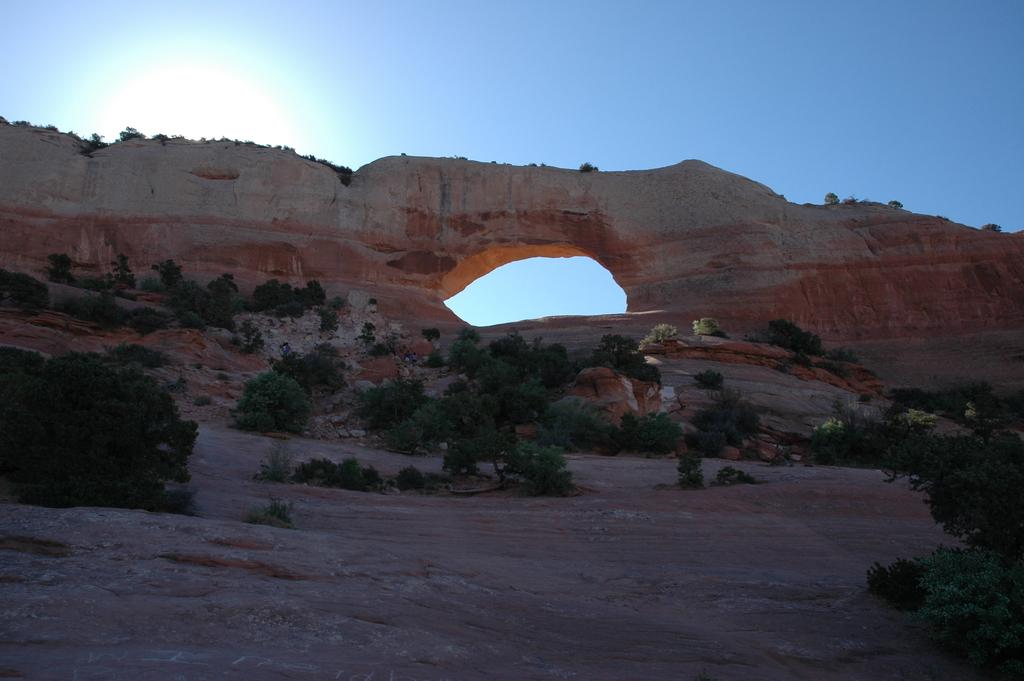What is the main feature in the foreground of the image? There is a hole in a rock in the foreground of the image. What can be seen on the surface at the bottom of the picture? There are plants on the surface in the bottom of the picture. What is providing shade in the top of the image? There is a shade of the sun in the top of the image. What is visible in the top of the image besides the shade? The sky is visible in the top of the image. What type of game is being played in the image? There is no game being played in the image; it features a hole in a rock, plants, a shade, and the sky. What part of the body is visible in the image? There is no specific body part visible in the image; it focuses on natural elements such as the rock, plants, and sky. 